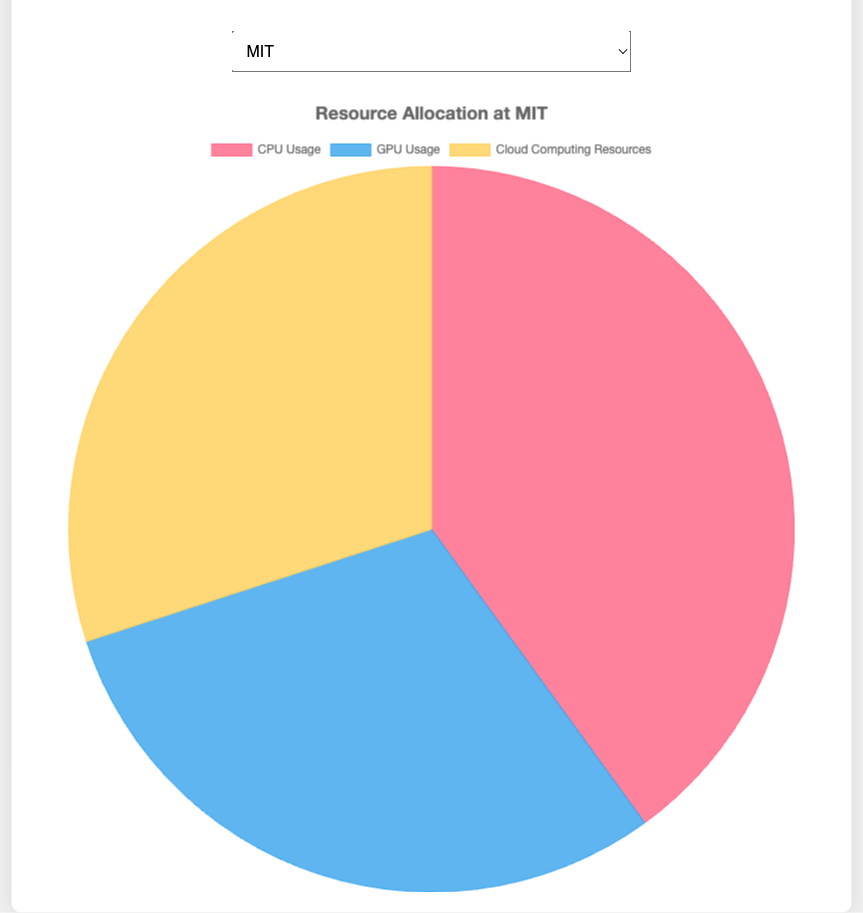What institution makes the most use of GPU resources for RG analysis? By looking at the colors and labels on the pie chart, identify the institution where the GPU usage slice is the largest. For GPU usage, it visually appears to be higher at the University of Cambridge due to the larger blue segment.
Answer: University of Cambridge Which institution allocates exactly one-third of its resources to cloud computing? Examine each institution’s pie chart to see if the cloud computing resources segment's size is exactly 30% of the total. The color hint for cloud computing is yellow. Both MIT and Stanford University allocate 30% to cloud computing, which is one-third.
Answer: MIT, Stanford University Is there an institution where GPU usage equals CPU usage? Check the pie charts to see if the sizes of the CPU and GPU segments are the same for any institution. GPU usage is blue and CPU usage is red. No institution has equal CPU and GPU usages.
Answer: No Which institution has the highest combined percentage of CPU and GPU usage? For each institution, sum the percentages of CPU usage (red) and GPU usage (blue). The institution with the highest sum is the one we’re looking for. For example, Tokyo Institute of Technology has (48% CPU + 32% GPU) = 80%. Verify visually. Stanford University has a total of 70% (50% CPU + 20% GPU), which is less. Thus, Tokyo Institute of Technology has the highest combined percentage.
Answer: Tokyo Institute of Technology What is the average cloud computing resource allocation across all institutions? Sum the cloud computing percentages of all institutions and divide by the number of institutions. The percentages are 30% (MIT), 30% (Stanford University), 20% (ETH Zurich), 25% (University of Cambridge), and 20% (Tokyo Institute of Technology). The total is 125%. The average is 125%/5 = 25%.
Answer: 25% Which institution has the smallest CPU usage percentage? Compare the sizes of the red segments (CPU usage) of each institution’s pie chart. Locate the smallest segment. University of Cambridge has the smallest segment in the red area for CPU usage with 35%.
Answer: University of Cambridge If you combine the cloud resources allocation of ETH Zurich and Tokyo Institute of Technology, would it be higher than the GPU usage of MIT? Add the values for cloud resource allocation for ETH Zurich (20%) and Tokyo Institute of Technology (20%), and compare it to the GPU usage of MIT (30%). (20% + 20% = 40%) which is indeed higher than 30%.
Answer: Yes Is there any institution where the GPU usage is higher than the CPU usage? Compare the blue segment (GPU usage) with the red segment (CPU usage) for each institution. University of Cambridge shows a higher GPU usage (40%) than CPU usage (35%).
Answer: University of Cambridge What's the total allocation percentage for Stanford University combined for GPU and cloud computing resources? Add the GPU usage percentage (blue) and the cloud computing percentage (yellow) for Stanford University. GPU is 20% and cloud computing is 30%, thus the combined total is 20% + 30% = 50%.
Answer: 50% 